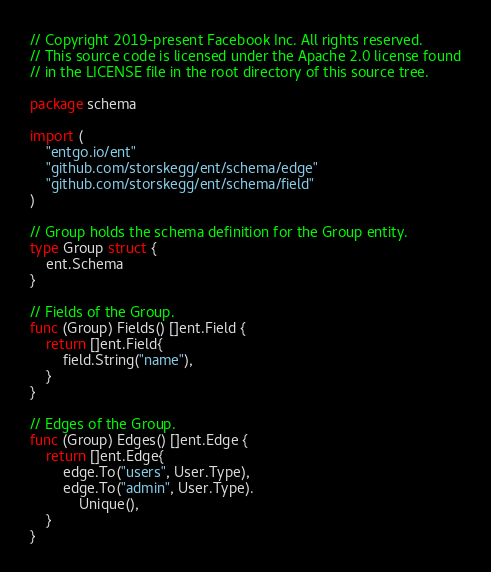<code> <loc_0><loc_0><loc_500><loc_500><_Go_>// Copyright 2019-present Facebook Inc. All rights reserved.
// This source code is licensed under the Apache 2.0 license found
// in the LICENSE file in the root directory of this source tree.

package schema

import (
	"entgo.io/ent"
	"github.com/storskegg/ent/schema/edge"
	"github.com/storskegg/ent/schema/field"
)

// Group holds the schema definition for the Group entity.
type Group struct {
	ent.Schema
}

// Fields of the Group.
func (Group) Fields() []ent.Field {
	return []ent.Field{
		field.String("name"),
	}
}

// Edges of the Group.
func (Group) Edges() []ent.Edge {
	return []ent.Edge{
		edge.To("users", User.Type),
		edge.To("admin", User.Type).
			Unique(),
	}
}
</code> 